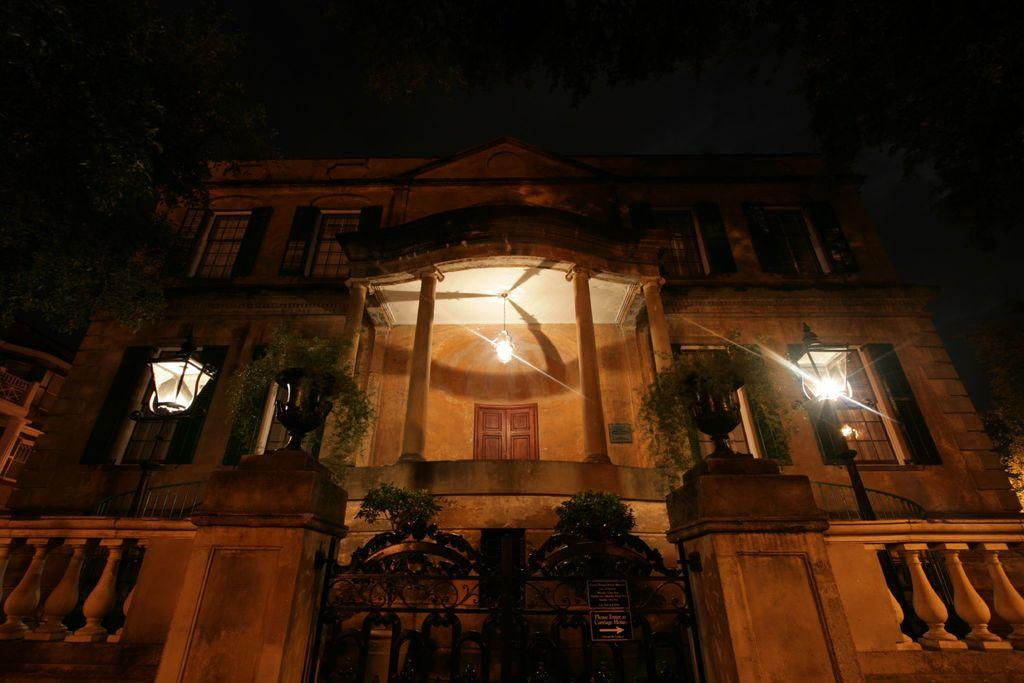What is the main structure in the image? There is a building in the image. What can be seen in the middle of the image? There are plants and lights in the middle of the image. What feature of the building is mentioned in the facts? The building has windows. What type of furniture is present in the image? There is no furniture mentioned or visible in the image. 